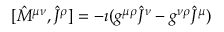<formula> <loc_0><loc_0><loc_500><loc_500>[ { \hat { M } } ^ { \mu \nu } , { \hat { J } } ^ { \rho } ] = - \imath ( g ^ { \mu \rho } { \hat { J } } ^ { \nu } - g ^ { \nu \rho } { \hat { J } } ^ { \mu } )</formula> 